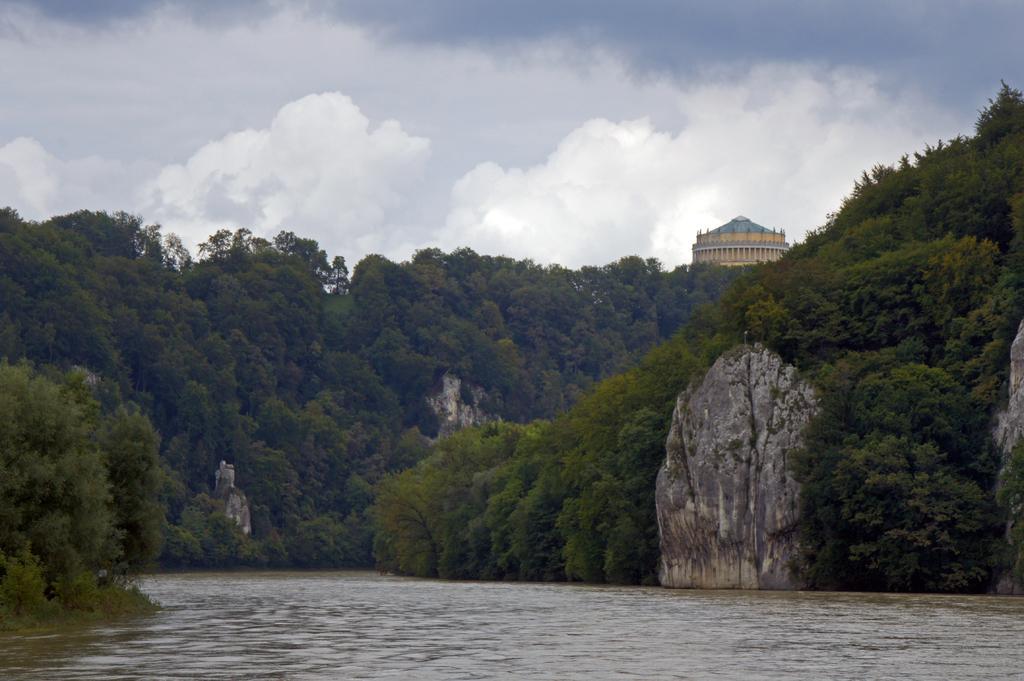Describe this image in one or two sentences. In the picture I can see water and there are few rocks,trees and a building in the background and the sky is cloudy. 